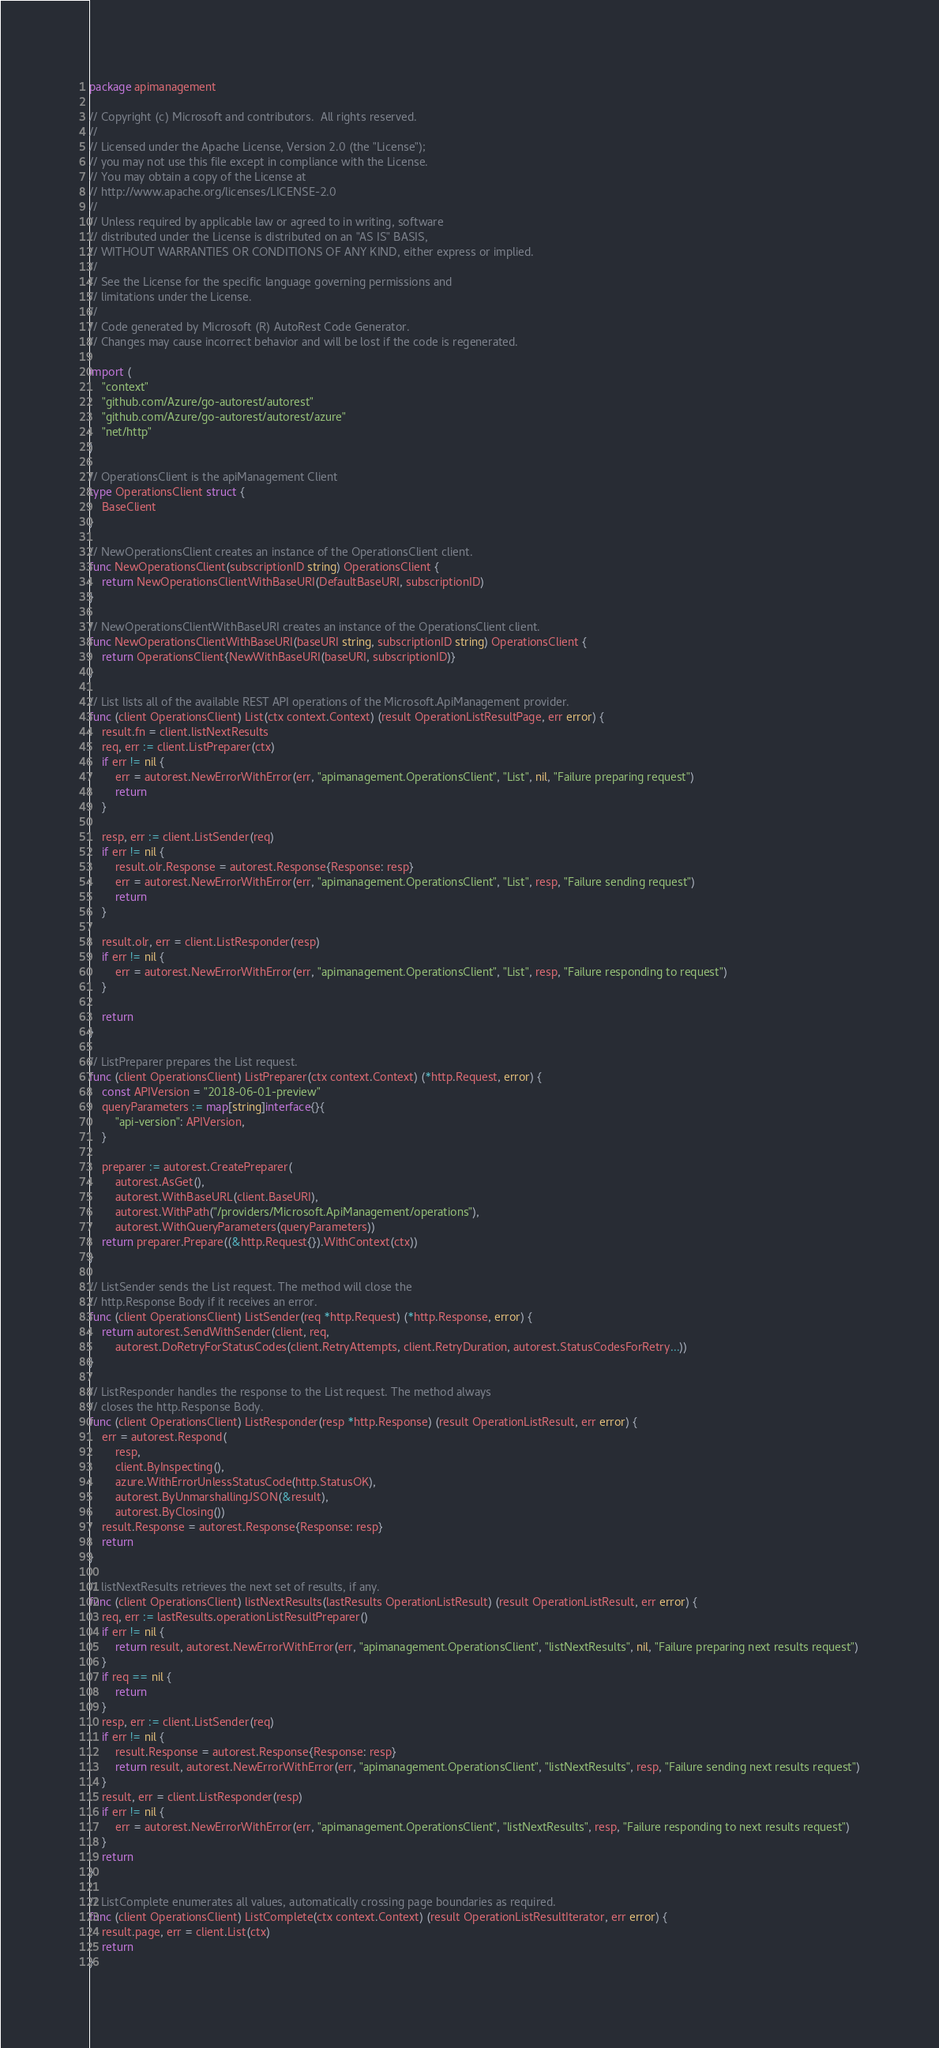<code> <loc_0><loc_0><loc_500><loc_500><_Go_>package apimanagement

// Copyright (c) Microsoft and contributors.  All rights reserved.
//
// Licensed under the Apache License, Version 2.0 (the "License");
// you may not use this file except in compliance with the License.
// You may obtain a copy of the License at
// http://www.apache.org/licenses/LICENSE-2.0
//
// Unless required by applicable law or agreed to in writing, software
// distributed under the License is distributed on an "AS IS" BASIS,
// WITHOUT WARRANTIES OR CONDITIONS OF ANY KIND, either express or implied.
//
// See the License for the specific language governing permissions and
// limitations under the License.
//
// Code generated by Microsoft (R) AutoRest Code Generator.
// Changes may cause incorrect behavior and will be lost if the code is regenerated.

import (
	"context"
	"github.com/Azure/go-autorest/autorest"
	"github.com/Azure/go-autorest/autorest/azure"
	"net/http"
)

// OperationsClient is the apiManagement Client
type OperationsClient struct {
	BaseClient
}

// NewOperationsClient creates an instance of the OperationsClient client.
func NewOperationsClient(subscriptionID string) OperationsClient {
	return NewOperationsClientWithBaseURI(DefaultBaseURI, subscriptionID)
}

// NewOperationsClientWithBaseURI creates an instance of the OperationsClient client.
func NewOperationsClientWithBaseURI(baseURI string, subscriptionID string) OperationsClient {
	return OperationsClient{NewWithBaseURI(baseURI, subscriptionID)}
}

// List lists all of the available REST API operations of the Microsoft.ApiManagement provider.
func (client OperationsClient) List(ctx context.Context) (result OperationListResultPage, err error) {
	result.fn = client.listNextResults
	req, err := client.ListPreparer(ctx)
	if err != nil {
		err = autorest.NewErrorWithError(err, "apimanagement.OperationsClient", "List", nil, "Failure preparing request")
		return
	}

	resp, err := client.ListSender(req)
	if err != nil {
		result.olr.Response = autorest.Response{Response: resp}
		err = autorest.NewErrorWithError(err, "apimanagement.OperationsClient", "List", resp, "Failure sending request")
		return
	}

	result.olr, err = client.ListResponder(resp)
	if err != nil {
		err = autorest.NewErrorWithError(err, "apimanagement.OperationsClient", "List", resp, "Failure responding to request")
	}

	return
}

// ListPreparer prepares the List request.
func (client OperationsClient) ListPreparer(ctx context.Context) (*http.Request, error) {
	const APIVersion = "2018-06-01-preview"
	queryParameters := map[string]interface{}{
		"api-version": APIVersion,
	}

	preparer := autorest.CreatePreparer(
		autorest.AsGet(),
		autorest.WithBaseURL(client.BaseURI),
		autorest.WithPath("/providers/Microsoft.ApiManagement/operations"),
		autorest.WithQueryParameters(queryParameters))
	return preparer.Prepare((&http.Request{}).WithContext(ctx))
}

// ListSender sends the List request. The method will close the
// http.Response Body if it receives an error.
func (client OperationsClient) ListSender(req *http.Request) (*http.Response, error) {
	return autorest.SendWithSender(client, req,
		autorest.DoRetryForStatusCodes(client.RetryAttempts, client.RetryDuration, autorest.StatusCodesForRetry...))
}

// ListResponder handles the response to the List request. The method always
// closes the http.Response Body.
func (client OperationsClient) ListResponder(resp *http.Response) (result OperationListResult, err error) {
	err = autorest.Respond(
		resp,
		client.ByInspecting(),
		azure.WithErrorUnlessStatusCode(http.StatusOK),
		autorest.ByUnmarshallingJSON(&result),
		autorest.ByClosing())
	result.Response = autorest.Response{Response: resp}
	return
}

// listNextResults retrieves the next set of results, if any.
func (client OperationsClient) listNextResults(lastResults OperationListResult) (result OperationListResult, err error) {
	req, err := lastResults.operationListResultPreparer()
	if err != nil {
		return result, autorest.NewErrorWithError(err, "apimanagement.OperationsClient", "listNextResults", nil, "Failure preparing next results request")
	}
	if req == nil {
		return
	}
	resp, err := client.ListSender(req)
	if err != nil {
		result.Response = autorest.Response{Response: resp}
		return result, autorest.NewErrorWithError(err, "apimanagement.OperationsClient", "listNextResults", resp, "Failure sending next results request")
	}
	result, err = client.ListResponder(resp)
	if err != nil {
		err = autorest.NewErrorWithError(err, "apimanagement.OperationsClient", "listNextResults", resp, "Failure responding to next results request")
	}
	return
}

// ListComplete enumerates all values, automatically crossing page boundaries as required.
func (client OperationsClient) ListComplete(ctx context.Context) (result OperationListResultIterator, err error) {
	result.page, err = client.List(ctx)
	return
}
</code> 